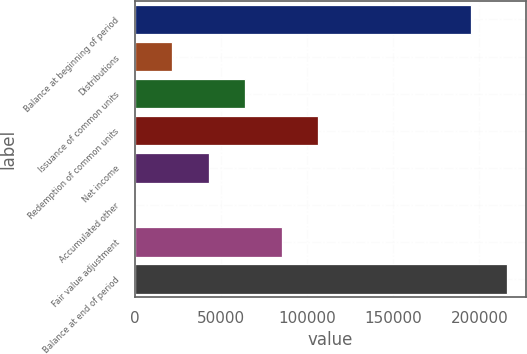Convert chart to OTSL. <chart><loc_0><loc_0><loc_500><loc_500><bar_chart><fcel>Balance at beginning of period<fcel>Distributions<fcel>Issuance of common units<fcel>Redemption of common units<fcel>Net income<fcel>Accumulated other<fcel>Fair value adjustment<fcel>Balance at end of period<nl><fcel>195030<fcel>21639.9<fcel>64143.7<fcel>106648<fcel>42891.8<fcel>388<fcel>85395.6<fcel>216282<nl></chart> 